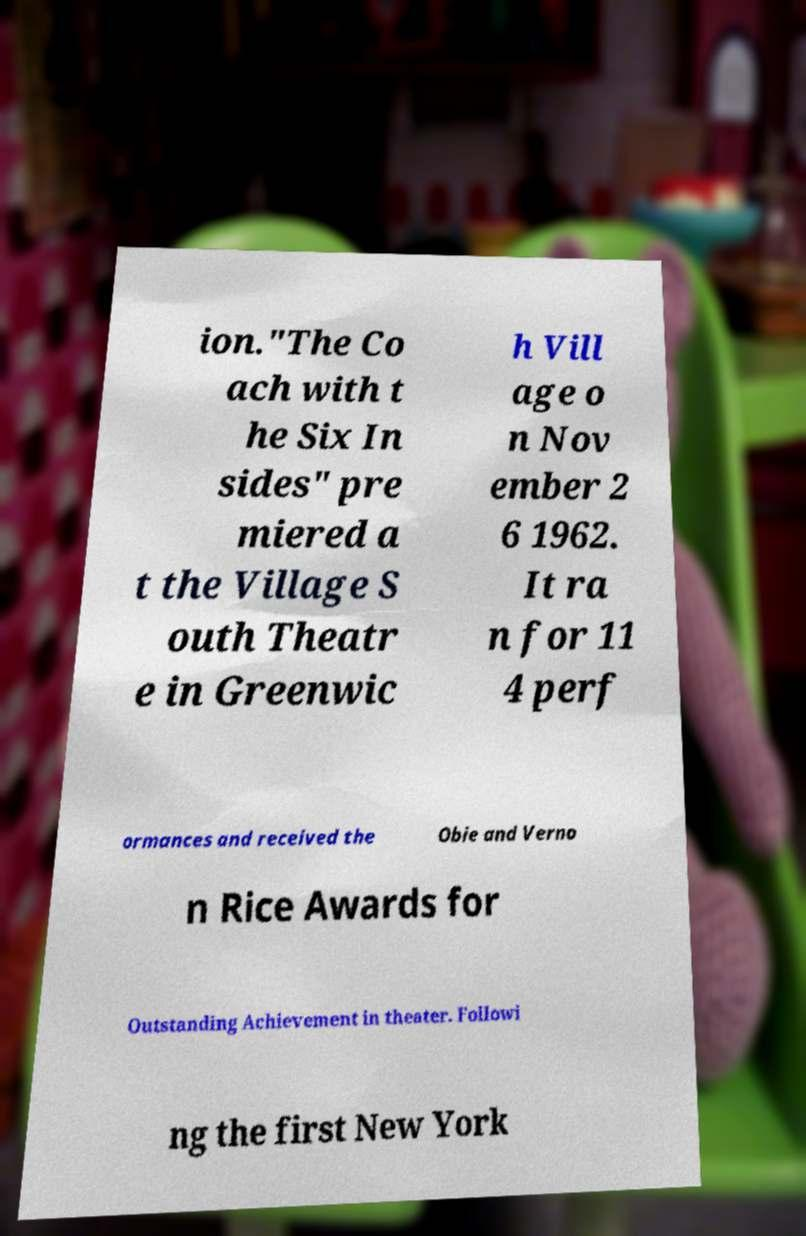Can you read and provide the text displayed in the image?This photo seems to have some interesting text. Can you extract and type it out for me? ion."The Co ach with t he Six In sides" pre miered a t the Village S outh Theatr e in Greenwic h Vill age o n Nov ember 2 6 1962. It ra n for 11 4 perf ormances and received the Obie and Verno n Rice Awards for Outstanding Achievement in theater. Followi ng the first New York 